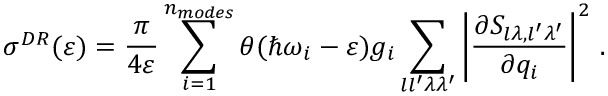<formula> <loc_0><loc_0><loc_500><loc_500>\sigma ^ { D R } ( \varepsilon ) = \frac { \pi } { 4 \varepsilon } \sum _ { i = 1 } ^ { n _ { m o d e s } } \theta ( \hbar { \omega } _ { i } - \varepsilon ) g _ { i } \sum _ { l l ^ { \prime } \lambda \lambda ^ { \prime } } \left | \frac { \partial S _ { l \lambda , l ^ { \prime } \lambda ^ { \prime } } } { \partial { q } _ { i } } \right | ^ { 2 } \, .</formula> 